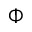Convert formula to latex. <formula><loc_0><loc_0><loc_500><loc_500>\Phi</formula> 